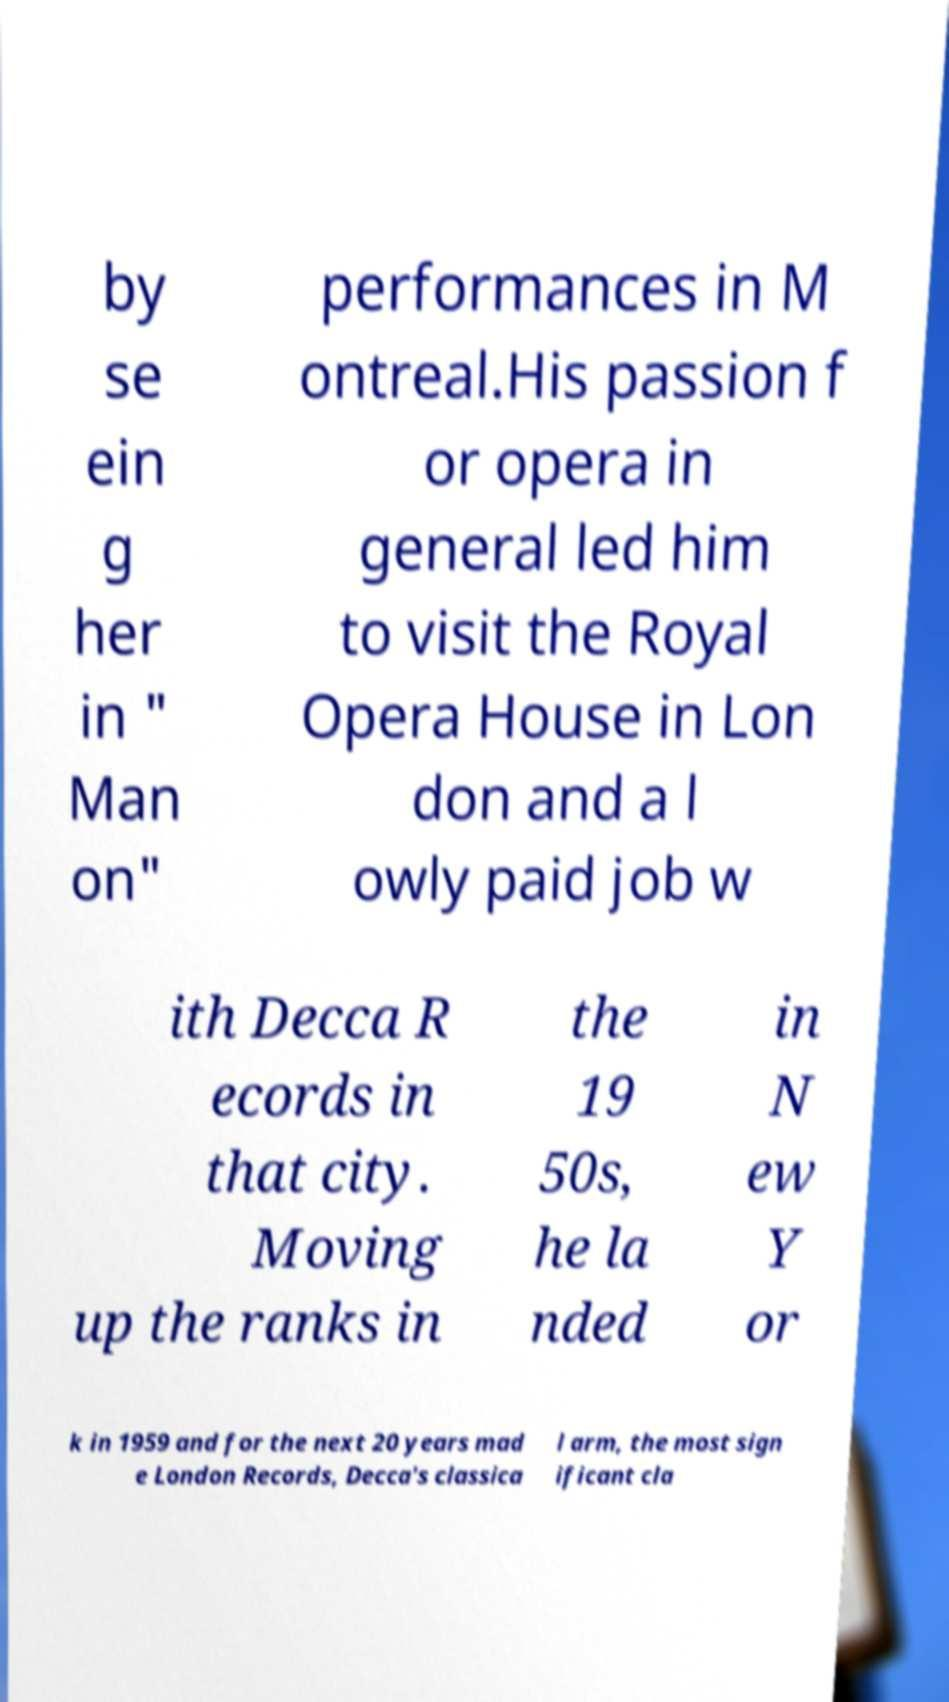Can you read and provide the text displayed in the image?This photo seems to have some interesting text. Can you extract and type it out for me? by se ein g her in " Man on" performances in M ontreal.His passion f or opera in general led him to visit the Royal Opera House in Lon don and a l owly paid job w ith Decca R ecords in that city. Moving up the ranks in the 19 50s, he la nded in N ew Y or k in 1959 and for the next 20 years mad e London Records, Decca's classica l arm, the most sign ificant cla 